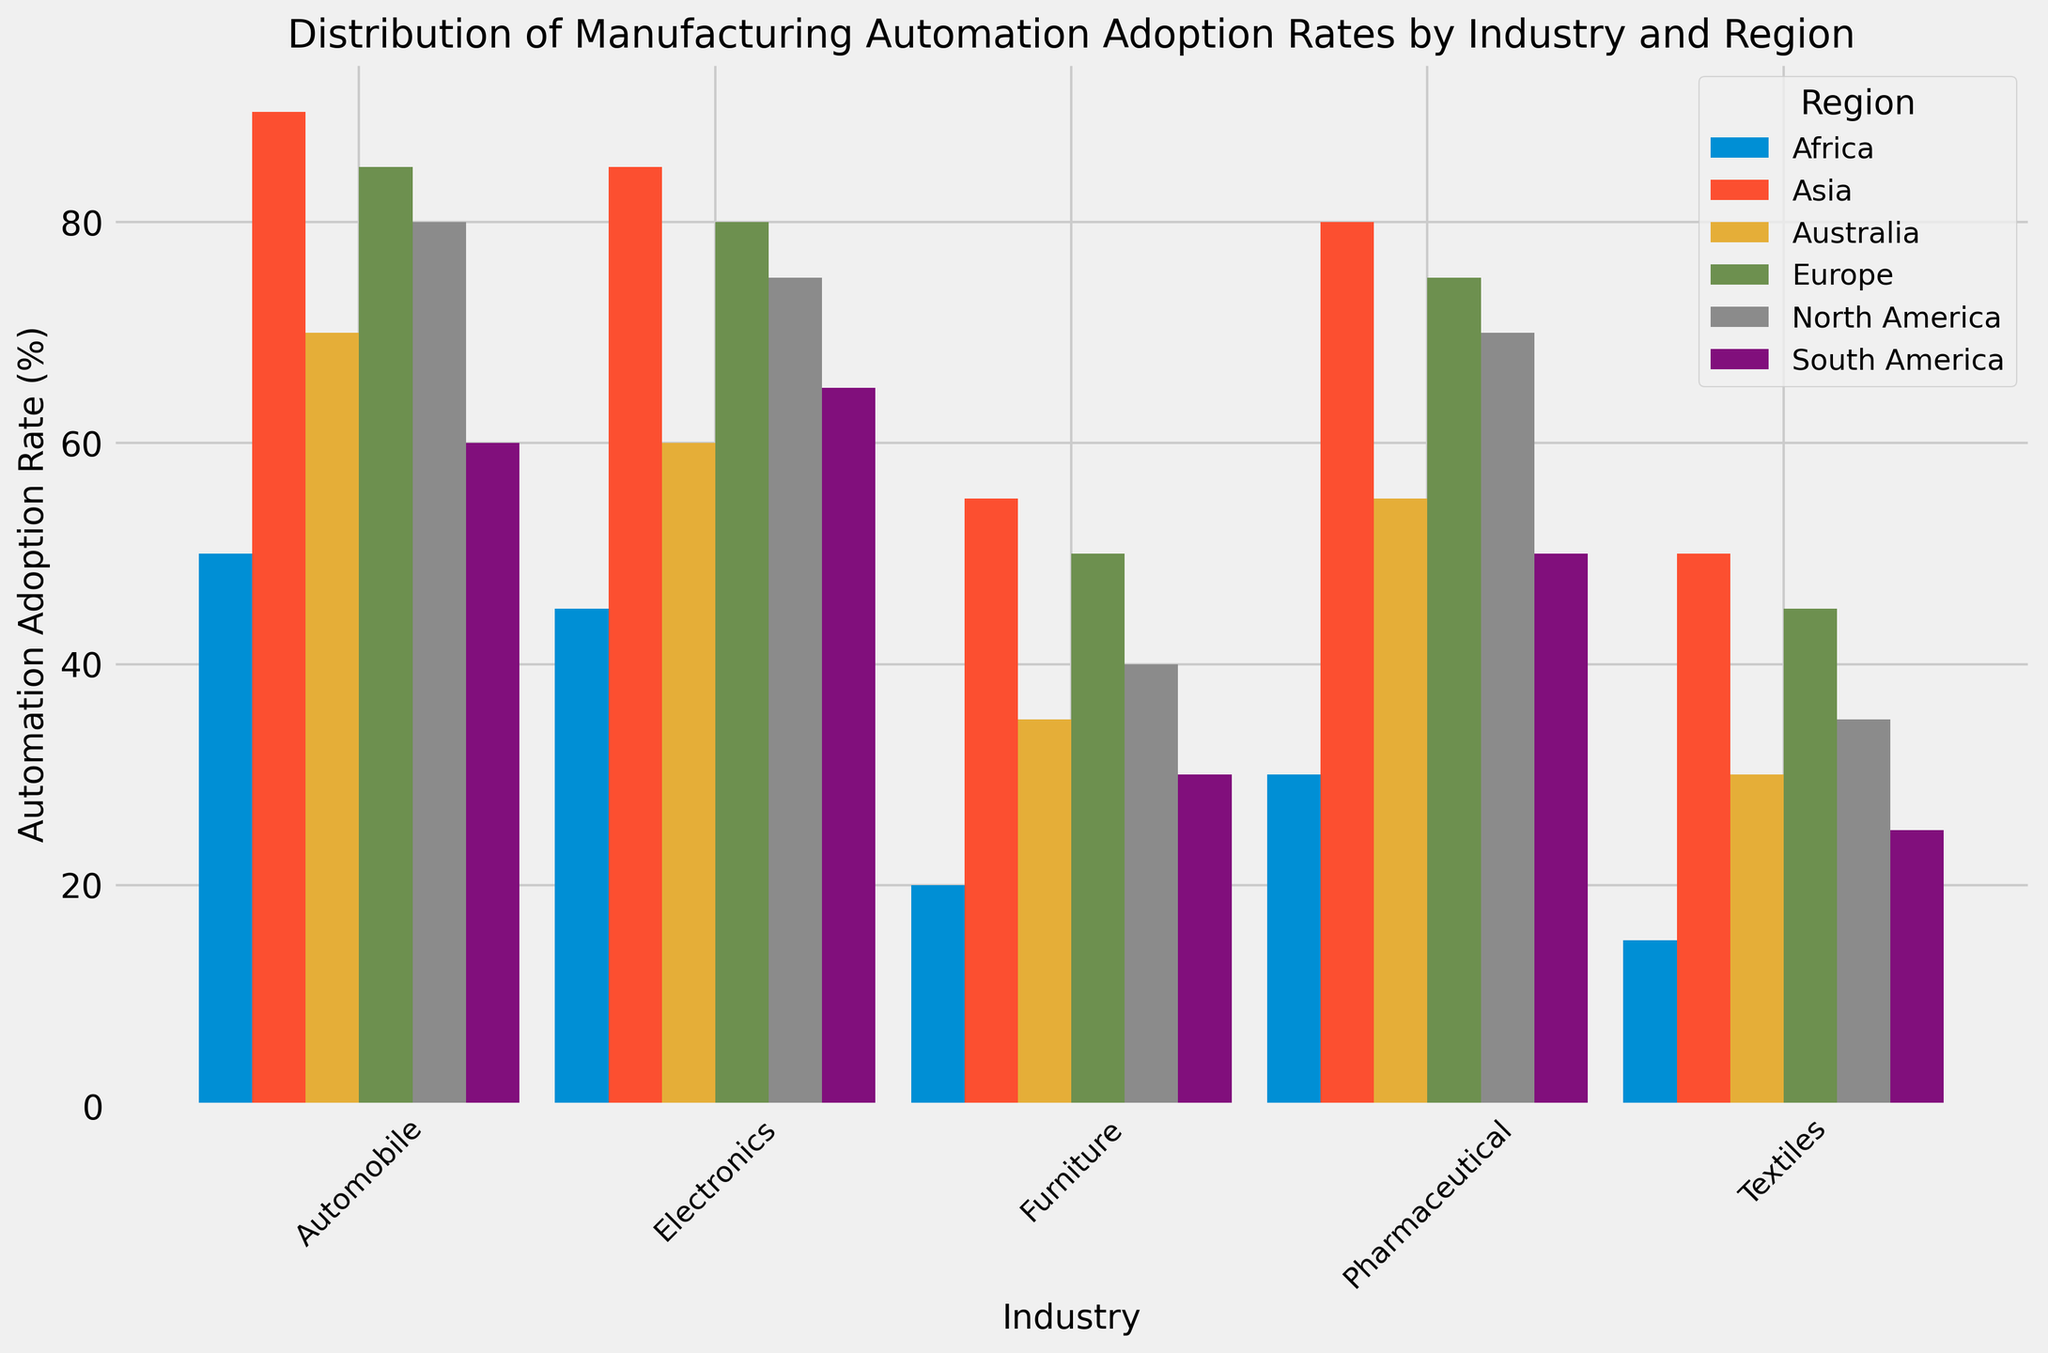What is the automation adoption rate for the Electronics industry in Europe? Identify the bar representing the Electronics industry in the Europe category and read its height.
Answer: 80% Which region has the highest automation adoption rate for the Furniture industry? Compare the heights of the bars representing the Furniture industry across all regions. Asia has the tallest bar.
Answer: Asia What is the difference in automation adoption rates between the Automobile industry in North America and South America? Identify the bars for the Automobile industry in North America and South America, then subtract the lower value from the higher one: 80 - 60.
Answer: 20 Which industry has the lowest average automation adoption rate across all regions? Calculate the average automation adoption rate for each industry across all regions and compare them. Textiles have the lowest average rate.
Answer: Textiles How many industries in Asia have an automation adoption rate of 80% or more? Count the number of bars in the Asia category that have a height of 80% or more. Three bars (Automobile, Electronics, Pharmaceutical) fit this criterion.
Answer: 3 What is the total automation adoption rate for the Furniture industry across Europe and Australia? Add the heights of the bars representing the Furniture industry in Europe and Australia: 50 + 35.
Answer: 85 Which region has the greatest variance in automation adoption rates across the industries? Determine the variance in automation adoption rates for each region and compare them. Africa has widely varying rates (from 50 down to 15).
Answer: Africa Is the automation adoption rate for Pharmaceuticals higher in North America or Australia? Compare the heights of the bars representing the Pharmaceutical industry in North America and Australia. North America's bar is taller.
Answer: North America Which industry has the most consistent automation adoption rates across all regions? Evaluate the bars for each industry to see which one has the smallest range of heights. The Pharmaceutical industry shows the most consistency.
Answer: Pharmaceutical 